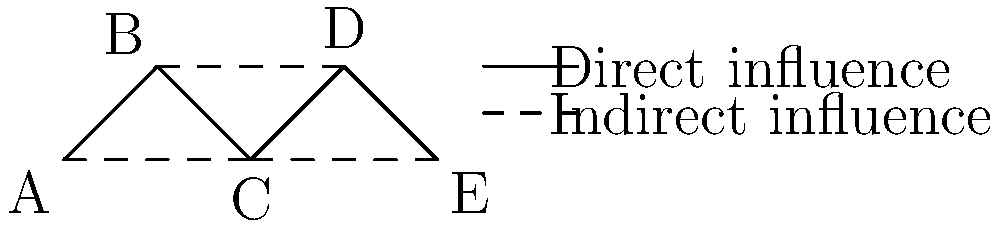In the network diagram above, nodes represent individuals in a community, and edges represent channels of ethical influence. Solid lines indicate direct influence, while dashed lines represent indirect influence. Given this ethical propagation network, which node would be most effective in disseminating a new ethical framework that prioritizes human judgment and empathy, and why? To determine the most effective node for disseminating a new ethical framework prioritizing human judgment and empathy, we need to consider both direct and indirect influences:

1. Analyze each node's connections:
   A: 2 direct (B, C), 0 indirect
   B: 2 direct (A, C), 1 indirect (D)
   C: 3 direct (A, B, D), 1 indirect (E)
   D: 2 direct (C, E), 1 indirect (B)
   E: 1 direct (D), 1 indirect (C)

2. Consider the importance of direct influence:
   Direct influence allows for more personal interaction, which is crucial for conveying the nuances of human judgment and empathy in ethical decision-making.

3. Evaluate the reach of each node:
   C has the highest number of direct connections (3) and can indirectly reach E through D.

4. Assess the central position:
   C occupies a central position in the network, bridging both ends of the community.

5. Consider the propagation of empathy:
   C's central position allows for a more empathetic understanding of different perspectives within the community, aligning with the ethical framework's emphasis on human judgment.

6. Evaluate the potential for cascading influence:
   Starting from C, the ethical framework can spread efficiently to all other nodes through both direct and indirect connections.

Therefore, node C would be the most effective in disseminating the new ethical framework due to its central position, high number of direct connections, and potential for cascading influence throughout the network.
Answer: Node C 